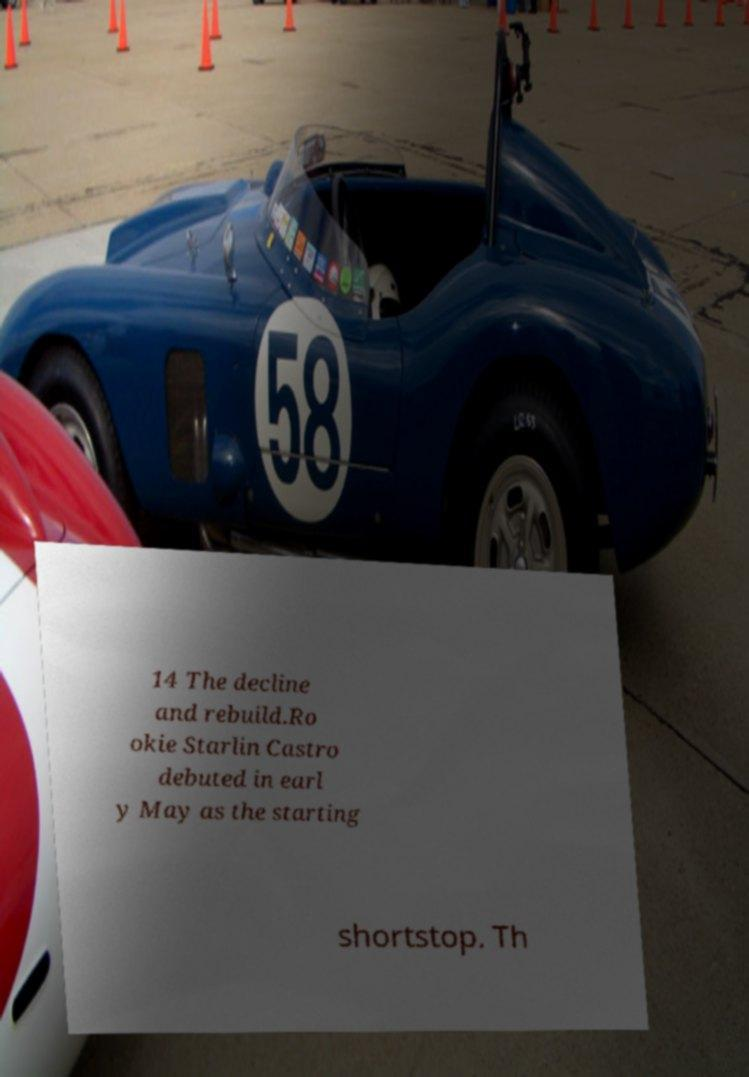Please identify and transcribe the text found in this image. 14 The decline and rebuild.Ro okie Starlin Castro debuted in earl y May as the starting shortstop. Th 